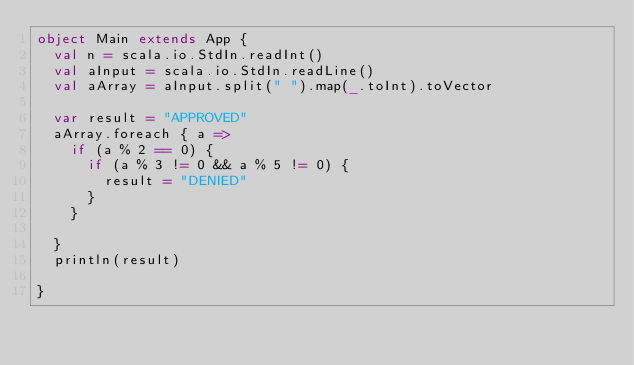Convert code to text. <code><loc_0><loc_0><loc_500><loc_500><_Scala_>object Main extends App {
  val n = scala.io.StdIn.readInt()
  val aInput = scala.io.StdIn.readLine()
  val aArray = aInput.split(" ").map(_.toInt).toVector

  var result = "APPROVED"
  aArray.foreach { a =>
    if (a % 2 == 0) {
      if (a % 3 != 0 && a % 5 != 0) {
        result = "DENIED"
      }
    }

  }
  println(result)

}</code> 